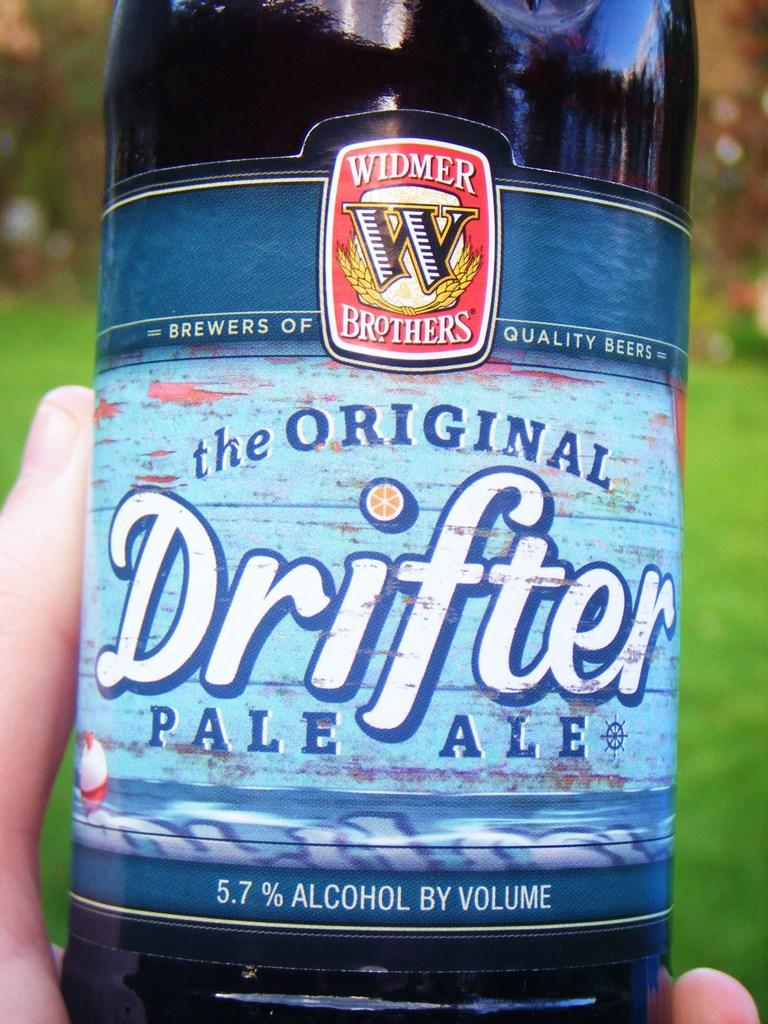<image>
Give a short and clear explanation of the subsequent image. A person holds a bottle of the Original Drifter Pale Ale. 